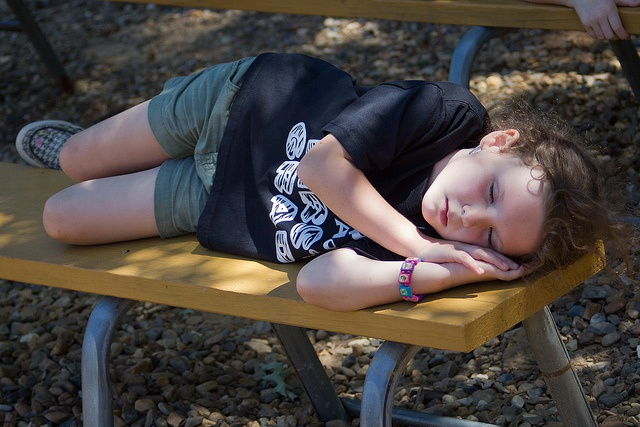Describe the objects in this image and their specific colors. I can see people in darkblue, black, gray, and darkgray tones, bench in darkblue, olive, black, and gray tones, and people in darkblue, gray, maroon, and black tones in this image. 